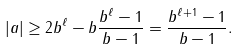Convert formula to latex. <formula><loc_0><loc_0><loc_500><loc_500>| a | \geq 2 b ^ { \ell } - b \frac { b ^ { \ell } - 1 } { b - 1 } = \frac { b ^ { \ell + 1 } - 1 } { b - 1 } .</formula> 